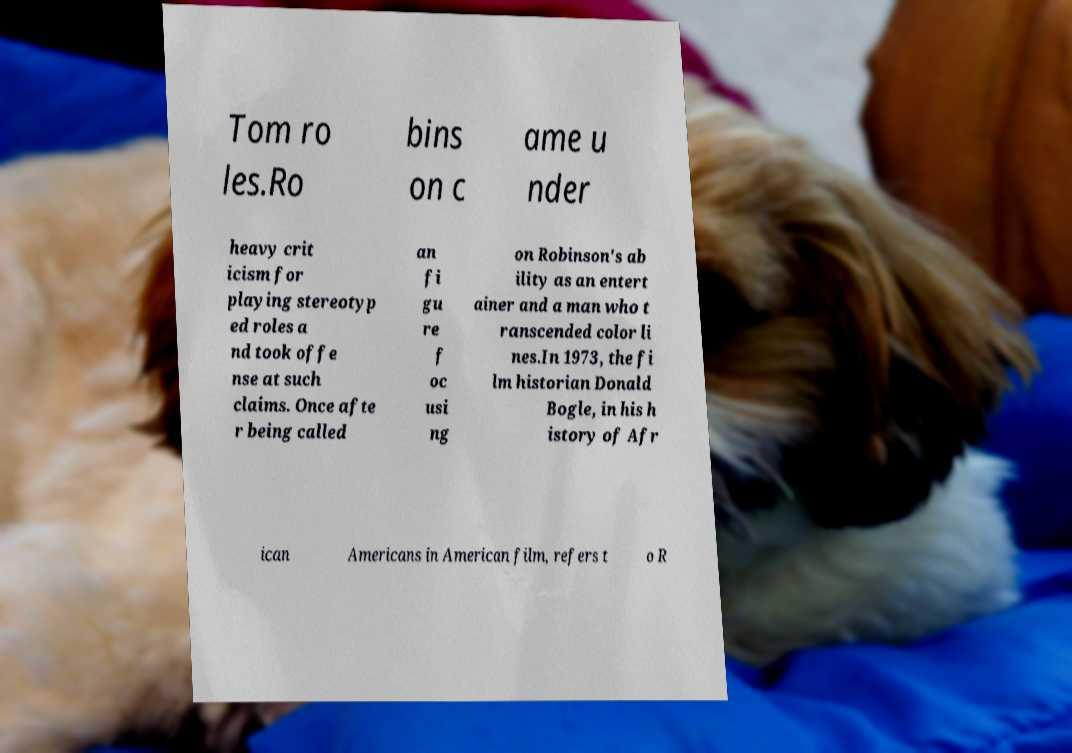Please identify and transcribe the text found in this image. Tom ro les.Ro bins on c ame u nder heavy crit icism for playing stereotyp ed roles a nd took offe nse at such claims. Once afte r being called an fi gu re f oc usi ng on Robinson's ab ility as an entert ainer and a man who t ranscended color li nes.In 1973, the fi lm historian Donald Bogle, in his h istory of Afr ican Americans in American film, refers t o R 